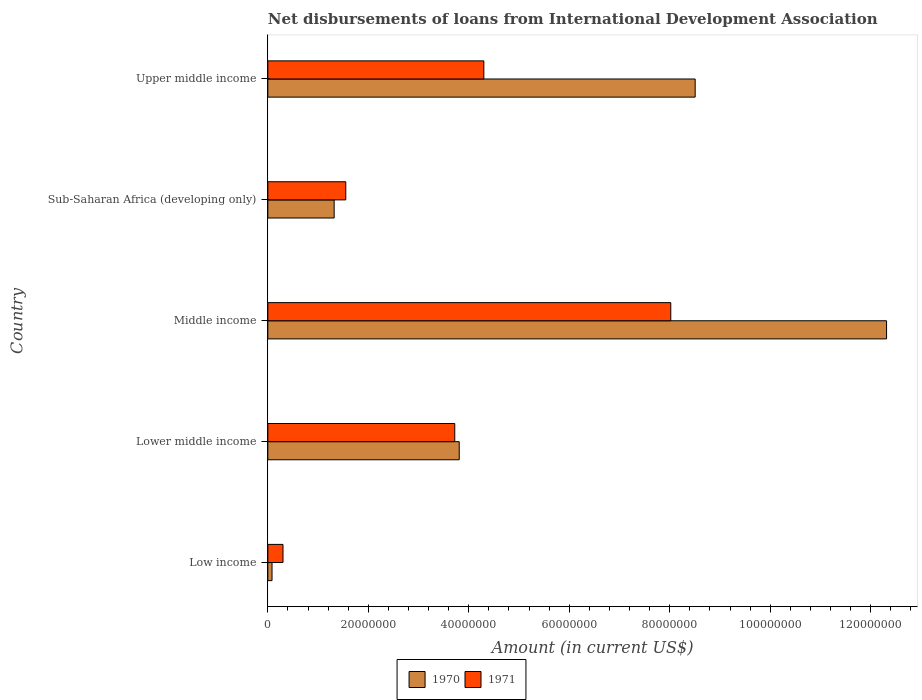What is the label of the 2nd group of bars from the top?
Offer a very short reply. Sub-Saharan Africa (developing only). In how many cases, is the number of bars for a given country not equal to the number of legend labels?
Provide a succinct answer. 0. What is the amount of loans disbursed in 1971 in Upper middle income?
Offer a very short reply. 4.30e+07. Across all countries, what is the maximum amount of loans disbursed in 1970?
Provide a succinct answer. 1.23e+08. Across all countries, what is the minimum amount of loans disbursed in 1971?
Your answer should be compact. 3.02e+06. What is the total amount of loans disbursed in 1971 in the graph?
Provide a short and direct response. 1.79e+08. What is the difference between the amount of loans disbursed in 1971 in Low income and that in Sub-Saharan Africa (developing only)?
Offer a very short reply. -1.25e+07. What is the difference between the amount of loans disbursed in 1970 in Lower middle income and the amount of loans disbursed in 1971 in Upper middle income?
Make the answer very short. -4.90e+06. What is the average amount of loans disbursed in 1971 per country?
Provide a succinct answer. 3.58e+07. What is the difference between the amount of loans disbursed in 1971 and amount of loans disbursed in 1970 in Lower middle income?
Provide a short and direct response. -8.88e+05. In how many countries, is the amount of loans disbursed in 1970 greater than 120000000 US$?
Ensure brevity in your answer.  1. What is the ratio of the amount of loans disbursed in 1970 in Middle income to that in Sub-Saharan Africa (developing only)?
Provide a succinct answer. 9.33. What is the difference between the highest and the second highest amount of loans disbursed in 1971?
Provide a succinct answer. 3.72e+07. What is the difference between the highest and the lowest amount of loans disbursed in 1971?
Give a very brief answer. 7.72e+07. Is the sum of the amount of loans disbursed in 1971 in Middle income and Upper middle income greater than the maximum amount of loans disbursed in 1970 across all countries?
Offer a terse response. Yes. What does the 1st bar from the top in Upper middle income represents?
Offer a very short reply. 1971. How many bars are there?
Provide a short and direct response. 10. How many countries are there in the graph?
Provide a succinct answer. 5. What is the difference between two consecutive major ticks on the X-axis?
Provide a succinct answer. 2.00e+07. Does the graph contain any zero values?
Offer a terse response. No. Where does the legend appear in the graph?
Your answer should be compact. Bottom center. What is the title of the graph?
Provide a succinct answer. Net disbursements of loans from International Development Association. Does "1965" appear as one of the legend labels in the graph?
Provide a succinct answer. No. What is the label or title of the X-axis?
Offer a terse response. Amount (in current US$). What is the Amount (in current US$) of 1970 in Low income?
Provide a short and direct response. 8.35e+05. What is the Amount (in current US$) of 1971 in Low income?
Make the answer very short. 3.02e+06. What is the Amount (in current US$) of 1970 in Lower middle income?
Provide a succinct answer. 3.81e+07. What is the Amount (in current US$) in 1971 in Lower middle income?
Provide a short and direct response. 3.72e+07. What is the Amount (in current US$) of 1970 in Middle income?
Provide a succinct answer. 1.23e+08. What is the Amount (in current US$) of 1971 in Middle income?
Provide a short and direct response. 8.02e+07. What is the Amount (in current US$) in 1970 in Sub-Saharan Africa (developing only)?
Your response must be concise. 1.32e+07. What is the Amount (in current US$) in 1971 in Sub-Saharan Africa (developing only)?
Your response must be concise. 1.55e+07. What is the Amount (in current US$) of 1970 in Upper middle income?
Offer a terse response. 8.51e+07. What is the Amount (in current US$) in 1971 in Upper middle income?
Give a very brief answer. 4.30e+07. Across all countries, what is the maximum Amount (in current US$) in 1970?
Your answer should be very brief. 1.23e+08. Across all countries, what is the maximum Amount (in current US$) in 1971?
Ensure brevity in your answer.  8.02e+07. Across all countries, what is the minimum Amount (in current US$) in 1970?
Make the answer very short. 8.35e+05. Across all countries, what is the minimum Amount (in current US$) of 1971?
Offer a terse response. 3.02e+06. What is the total Amount (in current US$) of 1970 in the graph?
Ensure brevity in your answer.  2.60e+08. What is the total Amount (in current US$) of 1971 in the graph?
Ensure brevity in your answer.  1.79e+08. What is the difference between the Amount (in current US$) in 1970 in Low income and that in Lower middle income?
Keep it short and to the point. -3.73e+07. What is the difference between the Amount (in current US$) of 1971 in Low income and that in Lower middle income?
Ensure brevity in your answer.  -3.42e+07. What is the difference between the Amount (in current US$) of 1970 in Low income and that in Middle income?
Offer a terse response. -1.22e+08. What is the difference between the Amount (in current US$) of 1971 in Low income and that in Middle income?
Your answer should be compact. -7.72e+07. What is the difference between the Amount (in current US$) in 1970 in Low income and that in Sub-Saharan Africa (developing only)?
Provide a succinct answer. -1.24e+07. What is the difference between the Amount (in current US$) in 1971 in Low income and that in Sub-Saharan Africa (developing only)?
Make the answer very short. -1.25e+07. What is the difference between the Amount (in current US$) in 1970 in Low income and that in Upper middle income?
Ensure brevity in your answer.  -8.42e+07. What is the difference between the Amount (in current US$) in 1971 in Low income and that in Upper middle income?
Offer a terse response. -4.00e+07. What is the difference between the Amount (in current US$) in 1970 in Lower middle income and that in Middle income?
Make the answer very short. -8.51e+07. What is the difference between the Amount (in current US$) of 1971 in Lower middle income and that in Middle income?
Ensure brevity in your answer.  -4.30e+07. What is the difference between the Amount (in current US$) of 1970 in Lower middle income and that in Sub-Saharan Africa (developing only)?
Provide a succinct answer. 2.49e+07. What is the difference between the Amount (in current US$) in 1971 in Lower middle income and that in Sub-Saharan Africa (developing only)?
Offer a terse response. 2.17e+07. What is the difference between the Amount (in current US$) of 1970 in Lower middle income and that in Upper middle income?
Keep it short and to the point. -4.70e+07. What is the difference between the Amount (in current US$) in 1971 in Lower middle income and that in Upper middle income?
Provide a succinct answer. -5.79e+06. What is the difference between the Amount (in current US$) in 1970 in Middle income and that in Sub-Saharan Africa (developing only)?
Make the answer very short. 1.10e+08. What is the difference between the Amount (in current US$) in 1971 in Middle income and that in Sub-Saharan Africa (developing only)?
Provide a short and direct response. 6.47e+07. What is the difference between the Amount (in current US$) of 1970 in Middle income and that in Upper middle income?
Ensure brevity in your answer.  3.81e+07. What is the difference between the Amount (in current US$) of 1971 in Middle income and that in Upper middle income?
Your answer should be compact. 3.72e+07. What is the difference between the Amount (in current US$) in 1970 in Sub-Saharan Africa (developing only) and that in Upper middle income?
Keep it short and to the point. -7.19e+07. What is the difference between the Amount (in current US$) of 1971 in Sub-Saharan Africa (developing only) and that in Upper middle income?
Offer a terse response. -2.75e+07. What is the difference between the Amount (in current US$) in 1970 in Low income and the Amount (in current US$) in 1971 in Lower middle income?
Ensure brevity in your answer.  -3.64e+07. What is the difference between the Amount (in current US$) of 1970 in Low income and the Amount (in current US$) of 1971 in Middle income?
Your answer should be compact. -7.94e+07. What is the difference between the Amount (in current US$) of 1970 in Low income and the Amount (in current US$) of 1971 in Sub-Saharan Africa (developing only)?
Provide a succinct answer. -1.47e+07. What is the difference between the Amount (in current US$) in 1970 in Low income and the Amount (in current US$) in 1971 in Upper middle income?
Your answer should be very brief. -4.22e+07. What is the difference between the Amount (in current US$) in 1970 in Lower middle income and the Amount (in current US$) in 1971 in Middle income?
Your response must be concise. -4.21e+07. What is the difference between the Amount (in current US$) of 1970 in Lower middle income and the Amount (in current US$) of 1971 in Sub-Saharan Africa (developing only)?
Ensure brevity in your answer.  2.26e+07. What is the difference between the Amount (in current US$) of 1970 in Lower middle income and the Amount (in current US$) of 1971 in Upper middle income?
Give a very brief answer. -4.90e+06. What is the difference between the Amount (in current US$) of 1970 in Middle income and the Amount (in current US$) of 1971 in Sub-Saharan Africa (developing only)?
Provide a succinct answer. 1.08e+08. What is the difference between the Amount (in current US$) in 1970 in Middle income and the Amount (in current US$) in 1971 in Upper middle income?
Give a very brief answer. 8.02e+07. What is the difference between the Amount (in current US$) of 1970 in Sub-Saharan Africa (developing only) and the Amount (in current US$) of 1971 in Upper middle income?
Make the answer very short. -2.98e+07. What is the average Amount (in current US$) in 1970 per country?
Give a very brief answer. 5.21e+07. What is the average Amount (in current US$) in 1971 per country?
Provide a short and direct response. 3.58e+07. What is the difference between the Amount (in current US$) in 1970 and Amount (in current US$) in 1971 in Low income?
Your answer should be very brief. -2.18e+06. What is the difference between the Amount (in current US$) in 1970 and Amount (in current US$) in 1971 in Lower middle income?
Your answer should be compact. 8.88e+05. What is the difference between the Amount (in current US$) of 1970 and Amount (in current US$) of 1971 in Middle income?
Keep it short and to the point. 4.30e+07. What is the difference between the Amount (in current US$) in 1970 and Amount (in current US$) in 1971 in Sub-Saharan Africa (developing only)?
Provide a short and direct response. -2.31e+06. What is the difference between the Amount (in current US$) of 1970 and Amount (in current US$) of 1971 in Upper middle income?
Make the answer very short. 4.21e+07. What is the ratio of the Amount (in current US$) of 1970 in Low income to that in Lower middle income?
Provide a short and direct response. 0.02. What is the ratio of the Amount (in current US$) in 1971 in Low income to that in Lower middle income?
Make the answer very short. 0.08. What is the ratio of the Amount (in current US$) in 1970 in Low income to that in Middle income?
Your response must be concise. 0.01. What is the ratio of the Amount (in current US$) in 1971 in Low income to that in Middle income?
Offer a very short reply. 0.04. What is the ratio of the Amount (in current US$) of 1970 in Low income to that in Sub-Saharan Africa (developing only)?
Give a very brief answer. 0.06. What is the ratio of the Amount (in current US$) of 1971 in Low income to that in Sub-Saharan Africa (developing only)?
Give a very brief answer. 0.19. What is the ratio of the Amount (in current US$) of 1970 in Low income to that in Upper middle income?
Keep it short and to the point. 0.01. What is the ratio of the Amount (in current US$) of 1971 in Low income to that in Upper middle income?
Give a very brief answer. 0.07. What is the ratio of the Amount (in current US$) in 1970 in Lower middle income to that in Middle income?
Your response must be concise. 0.31. What is the ratio of the Amount (in current US$) of 1971 in Lower middle income to that in Middle income?
Provide a succinct answer. 0.46. What is the ratio of the Amount (in current US$) of 1970 in Lower middle income to that in Sub-Saharan Africa (developing only)?
Your response must be concise. 2.89. What is the ratio of the Amount (in current US$) of 1971 in Lower middle income to that in Sub-Saharan Africa (developing only)?
Give a very brief answer. 2.4. What is the ratio of the Amount (in current US$) in 1970 in Lower middle income to that in Upper middle income?
Ensure brevity in your answer.  0.45. What is the ratio of the Amount (in current US$) in 1971 in Lower middle income to that in Upper middle income?
Ensure brevity in your answer.  0.87. What is the ratio of the Amount (in current US$) in 1970 in Middle income to that in Sub-Saharan Africa (developing only)?
Your answer should be compact. 9.33. What is the ratio of the Amount (in current US$) in 1971 in Middle income to that in Sub-Saharan Africa (developing only)?
Keep it short and to the point. 5.17. What is the ratio of the Amount (in current US$) in 1970 in Middle income to that in Upper middle income?
Make the answer very short. 1.45. What is the ratio of the Amount (in current US$) of 1971 in Middle income to that in Upper middle income?
Your answer should be compact. 1.87. What is the ratio of the Amount (in current US$) in 1970 in Sub-Saharan Africa (developing only) to that in Upper middle income?
Offer a terse response. 0.16. What is the ratio of the Amount (in current US$) of 1971 in Sub-Saharan Africa (developing only) to that in Upper middle income?
Offer a very short reply. 0.36. What is the difference between the highest and the second highest Amount (in current US$) in 1970?
Provide a succinct answer. 3.81e+07. What is the difference between the highest and the second highest Amount (in current US$) of 1971?
Give a very brief answer. 3.72e+07. What is the difference between the highest and the lowest Amount (in current US$) of 1970?
Ensure brevity in your answer.  1.22e+08. What is the difference between the highest and the lowest Amount (in current US$) in 1971?
Your response must be concise. 7.72e+07. 